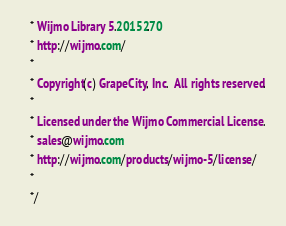<code> <loc_0><loc_0><loc_500><loc_500><_CSS_>    * Wijmo Library 5.20152.70
    * http://wijmo.com/
    *
    * Copyright(c) GrapeCity, Inc.  All rights reserved.
    * 
    * Licensed under the Wijmo Commercial License. 
    * sales@wijmo.com
    * http://wijmo.com/products/wijmo-5/license/
    *
    */</code> 